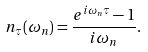<formula> <loc_0><loc_0><loc_500><loc_500>n _ { \tau } ( \omega _ { n } ) = \frac { e ^ { i \omega _ { n } \tau } - 1 } { i \omega _ { n } } .</formula> 